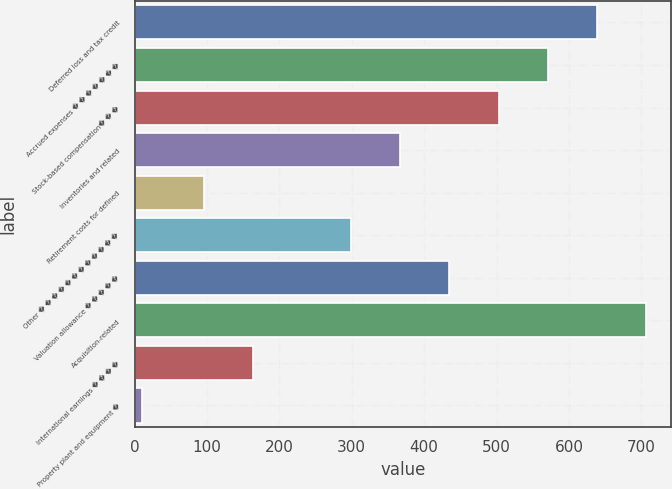Convert chart to OTSL. <chart><loc_0><loc_0><loc_500><loc_500><bar_chart><fcel>Deferred loss and tax credit<fcel>Accrued expenses � � � � � � �<fcel>Stock-based compensation� � �<fcel>Inventories and related<fcel>Retirement costs for defined<fcel>Other � � � � � � � � � � � �<fcel>Valuation allowance � � � � �<fcel>Acquisition-related<fcel>International earnings � � � �<fcel>Property plant and equipment �<nl><fcel>638.4<fcel>570.6<fcel>502.8<fcel>367.2<fcel>96<fcel>299.4<fcel>435<fcel>706.2<fcel>163.8<fcel>10<nl></chart> 